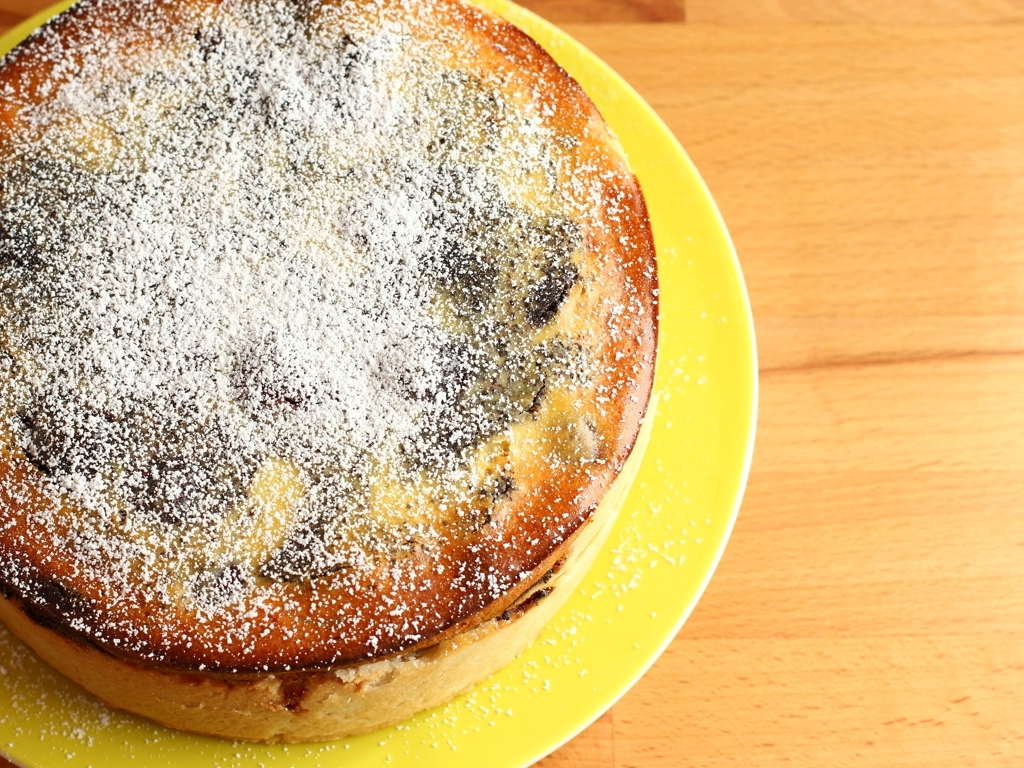Are the wood grain details clear? The image's focus isn't on wood grain details but rather on a well-baked cake dusted with powdered sugar, which sits on a yellow plate with a wooden table in the background. While some wood grain can be seen, it's not the main subject of the photo. 